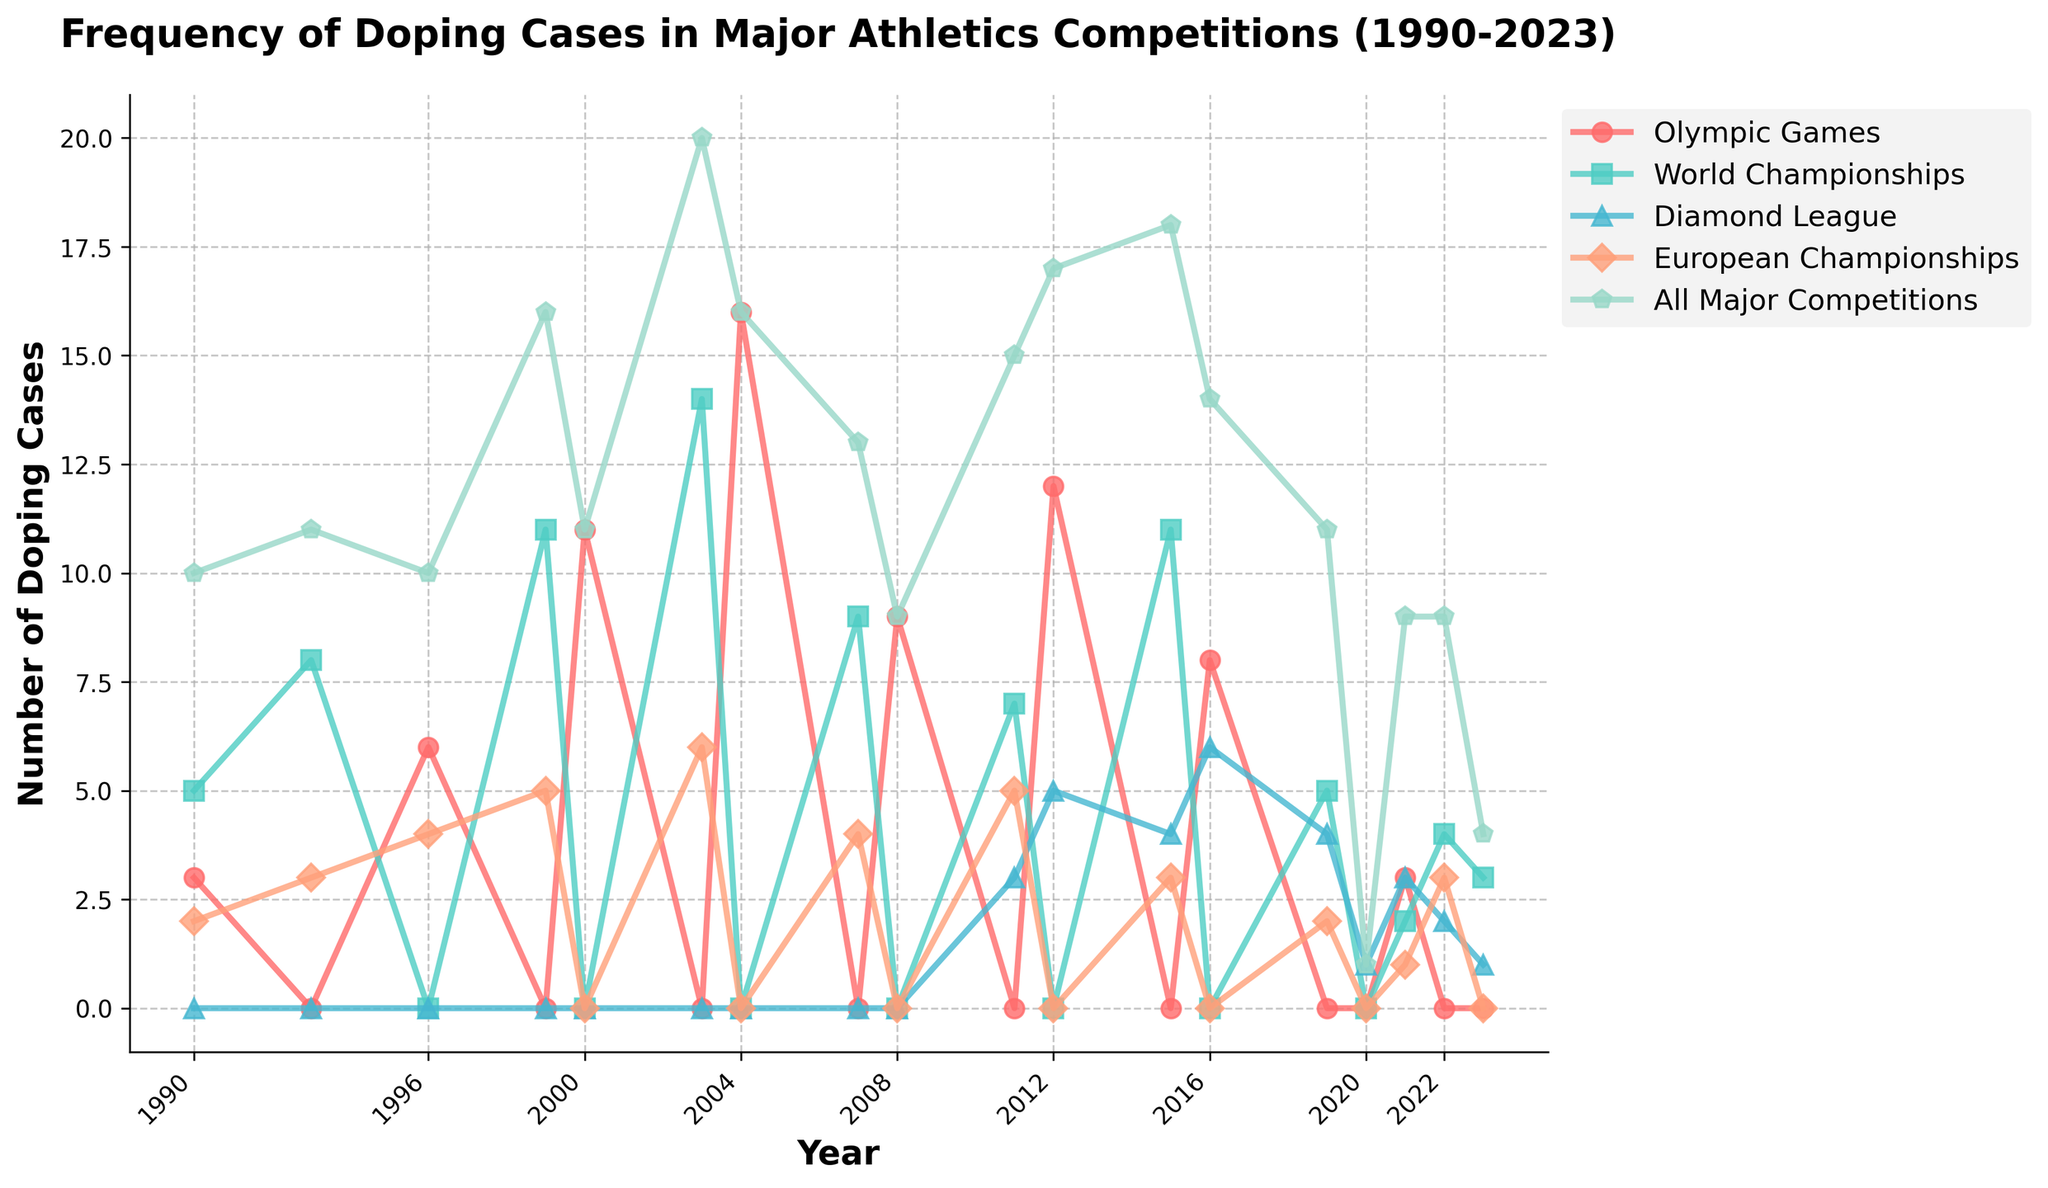What year had the highest number of doping cases in the Olympic Games? The peak for the Olympic Games can be identified by locating the highest point on the red line in the figure. The highest doping cases occurred in 2004.
Answer: 2004 How does the frequency of doping cases in the World Championships compare between 1999 and 2003? Compare the height of the green line at 1999 and 2003. The frequency increased from 11 in 1999 to 14 in 2003.
Answer: Increased What is the average number of doping cases detected in the European Championships over the entire period? Find the sum of the doping cases in the European Championships and divide by the number of years it was recorded. (2+3+4+5+6+4+3+5+0+3)/10 = 3.5
Answer: 3.5 Which competition experienced a peak in doping cases in 2012? Look at the lines in the figure; the dark blue line representing Diamond League peaks in 2012 at 5 doping cases.
Answer: Diamond League Between 1990 and 2023, which year had the lowest combined doping cases across all major competitions? Observing the gray line representing All Major Competitions, the lowest combined number of doping cases (excluding non-zero years) appears to be 2020 with 1 case.
Answer: 2020 What is the combined total number of doping cases detected in the Olympic Games for the years 2000 and 2004? Add the doping cases for the Olympic Games in 2000 and 2004 (11 + 16 = 27).
Answer: 27 How do the doping cases in the Diamond League in 2020 compare to those in 2023? The light blue line for the Diamond League shows 1 case in 2020 and 1 case in 2023, indicating they are equal.
Answer: Equal What is the trend in the frequency of doping cases in the Olympic Games from 2008 to 2021? Follow the red line from 2008 onwards. There's a decline from 9 in 2008 to 0 in 2019, with a slight increase to 3 in 2021.
Answer: Fluctuating downward In which year did the World Championships see more doping cases than the European Championships and the Diamond League combined? Compare the green line (World Championships) with the sum of the blue (European Championships) and light blue (Diamond League) lines. In 2003, the World Championships had 14 cases, and the sum of the other two competitions is less.
Answer: 2003 What overall trend can be observed for the total number of doping cases across all major competitions from 1990 to 2023? Looking at the gray line representing all major competitions, there's an overall fluctuating trend, peaking in 2003 and 2012 and generally decreasing after 2012.
Answer: Fluctuating downward 